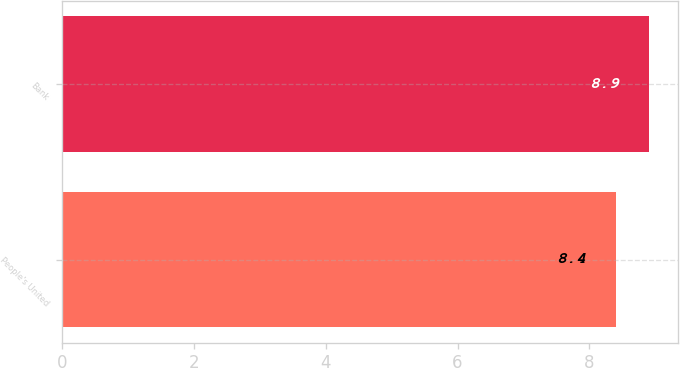Convert chart to OTSL. <chart><loc_0><loc_0><loc_500><loc_500><bar_chart><fcel>People's United<fcel>Bank<nl><fcel>8.4<fcel>8.9<nl></chart> 